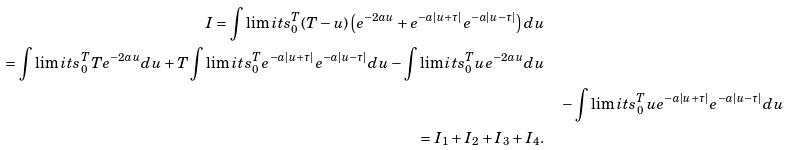Convert formula to latex. <formula><loc_0><loc_0><loc_500><loc_500>I = \int \lim i t s _ { 0 } ^ { T } ( T - u ) \left ( e ^ { - 2 a u } + e ^ { - a | u + \tau | } e ^ { - a | u - \tau | } \right ) d u \\ = \int \lim i t s _ { 0 } ^ { T } T e ^ { - 2 a u } d u + T \int \lim i t s _ { 0 } ^ { T } e ^ { - a | u + \tau | } e ^ { - a | u - \tau | } d u - \int \lim i t s _ { 0 } ^ { T } u e ^ { - 2 a u } d u \\ & \quad - \int \lim i t s _ { 0 } ^ { T } u e ^ { - a | u + \tau | } e ^ { - a | u - \tau | } d u \\ = I _ { 1 } + I _ { 2 } + I _ { 3 } + I _ { 4 } .</formula> 